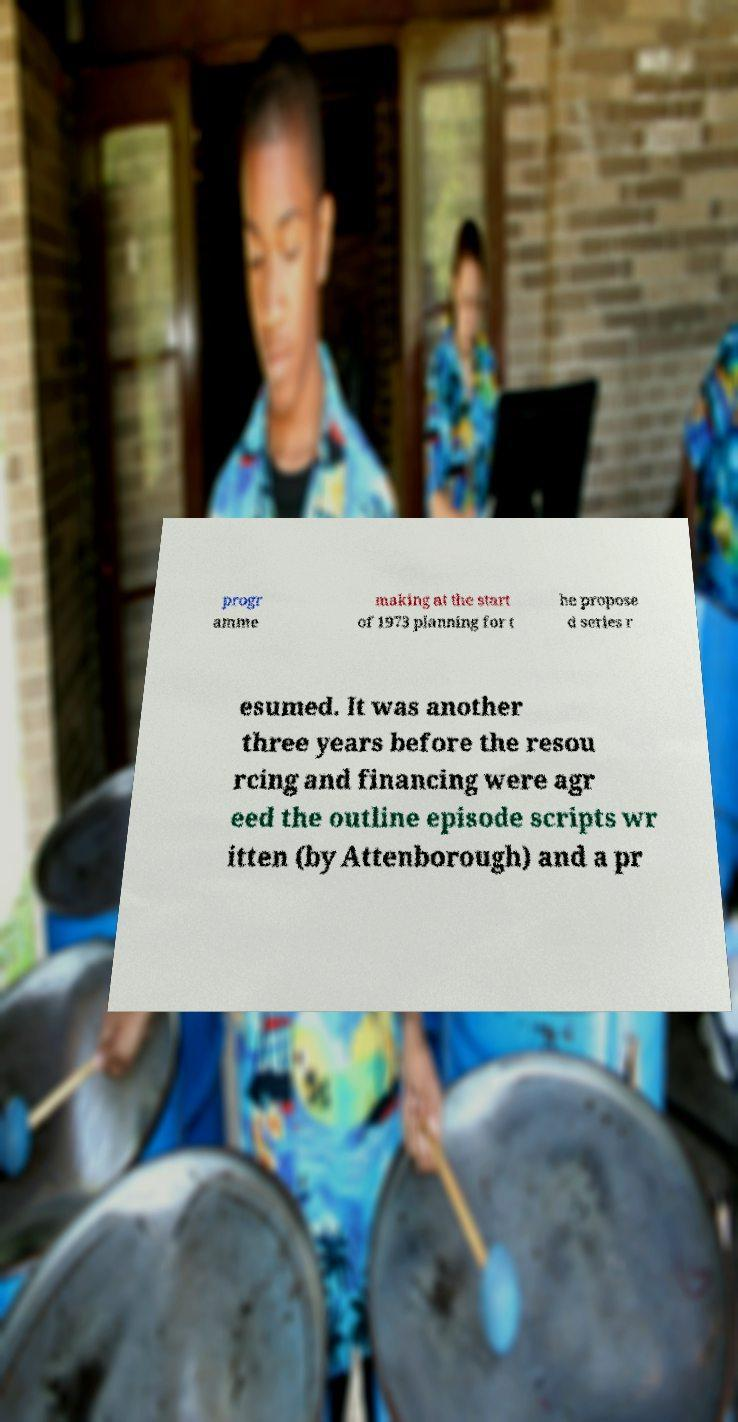Please read and relay the text visible in this image. What does it say? progr amme making at the start of 1973 planning for t he propose d series r esumed. It was another three years before the resou rcing and financing were agr eed the outline episode scripts wr itten (by Attenborough) and a pr 